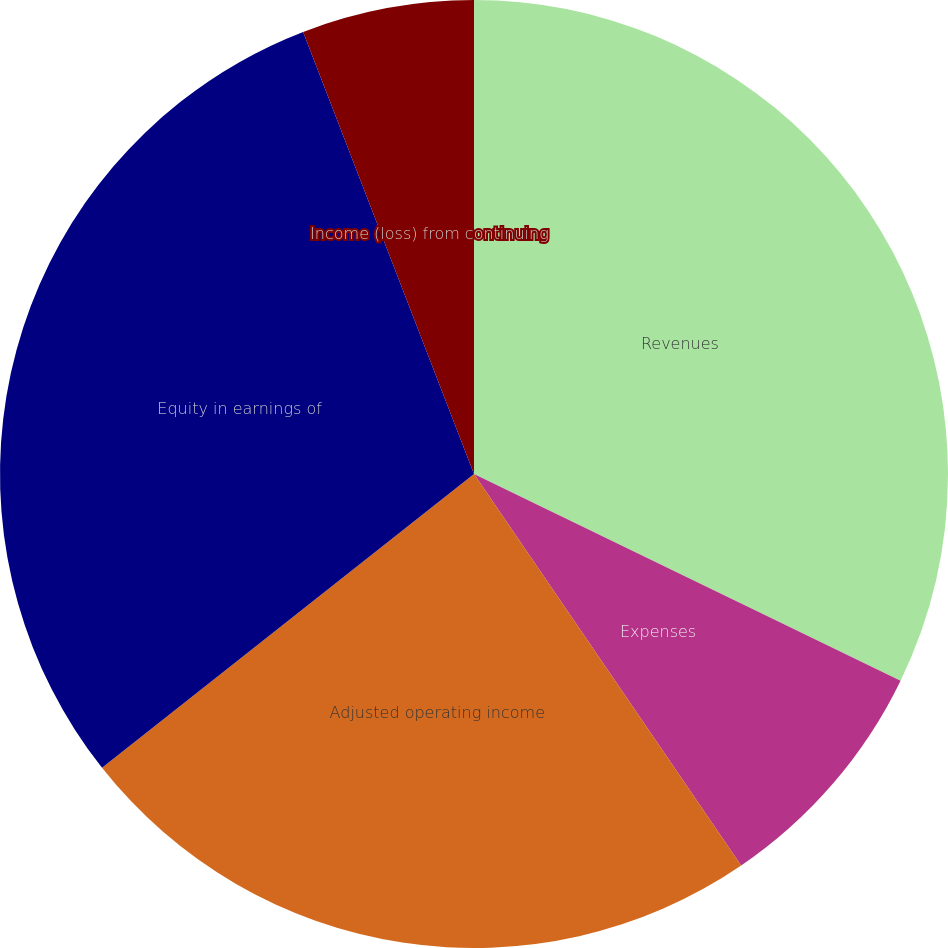<chart> <loc_0><loc_0><loc_500><loc_500><pie_chart><fcel>Revenues<fcel>Expenses<fcel>Adjusted operating income<fcel>Equity in earnings of<fcel>Income (loss) from continuing<nl><fcel>32.18%<fcel>8.29%<fcel>23.89%<fcel>29.77%<fcel>5.87%<nl></chart> 